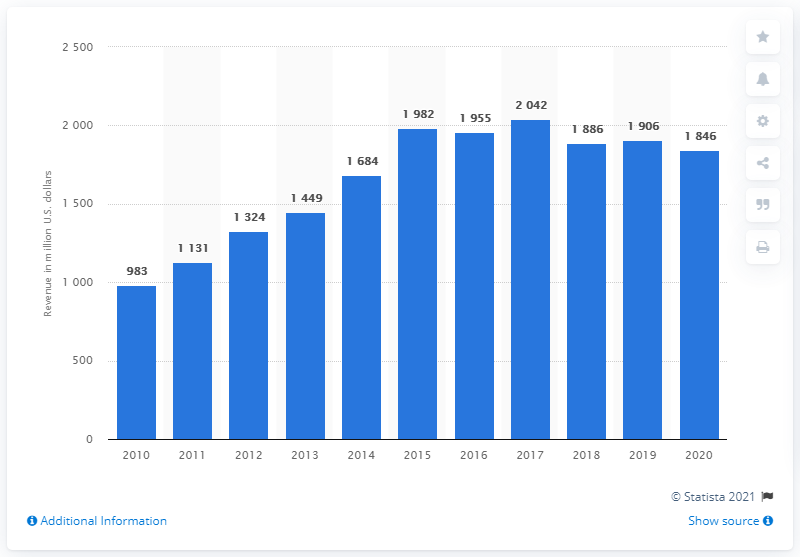List a handful of essential elements in this visual. The global revenue of Converse in 2020 was $1846. 